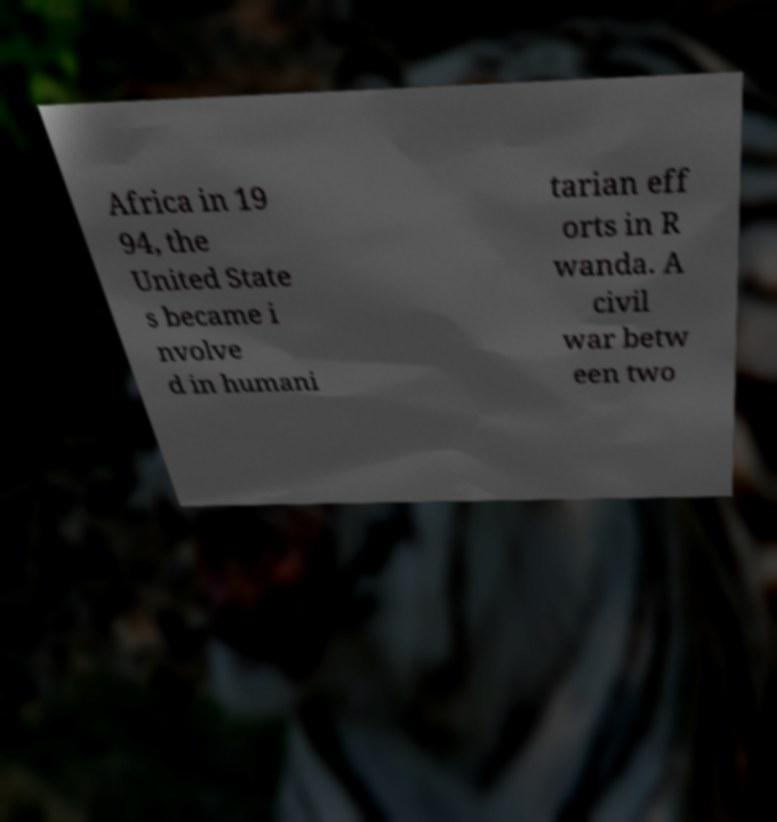There's text embedded in this image that I need extracted. Can you transcribe it verbatim? Africa in 19 94, the United State s became i nvolve d in humani tarian eff orts in R wanda. A civil war betw een two 